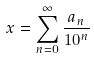Convert formula to latex. <formula><loc_0><loc_0><loc_500><loc_500>x = \sum _ { n = 0 } ^ { \infty } \frac { a _ { n } } { 1 0 ^ { n } }</formula> 